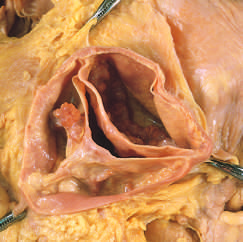what does one cusp have at its center?
Answer the question using a single word or phrase. A partial fusion 